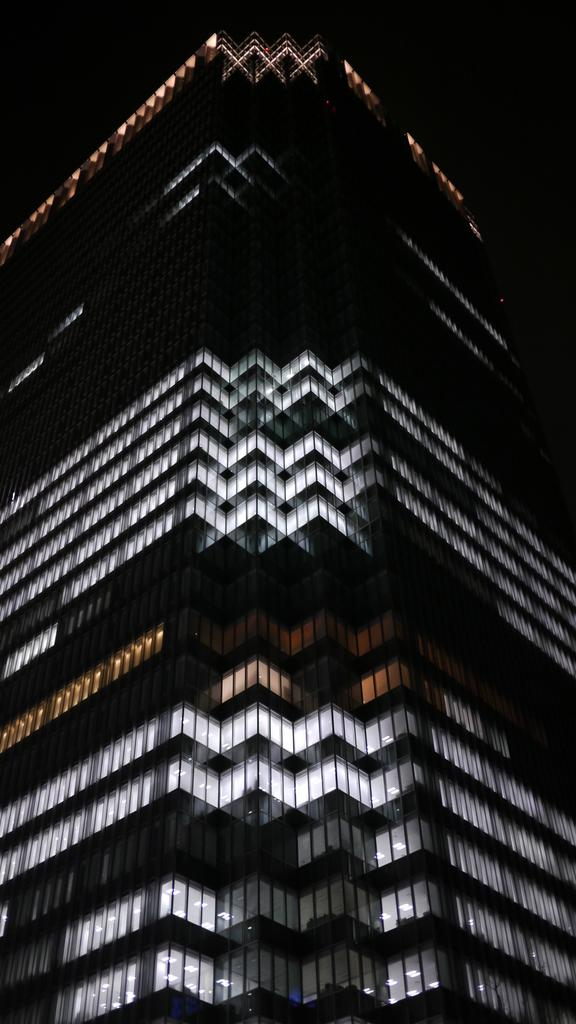What type of structure is visible in the image? There is a building in the image. What colors are used in the building? The building is in white and black color. How can you describe the color of the top of the building? The top of the building appears to be black in color. Can you tell anything about the lighting conditions in the image? The image might have been taken in the dark. Reasoning: Let' Let's think step by step in order to produce the conversation. We start by identifying the main subject in the image, which is the building. Then, we describe the colors of the building, focusing on the white and black color scheme and the black top. Finally, we speculate about the lighting conditions based on the information provided, suggesting that the image might have been taken in the dark. Absurd Question/Answer: How does the crow contribute to the thrill of the image? There is no crow present in the image, so it cannot contribute to the thrill. 